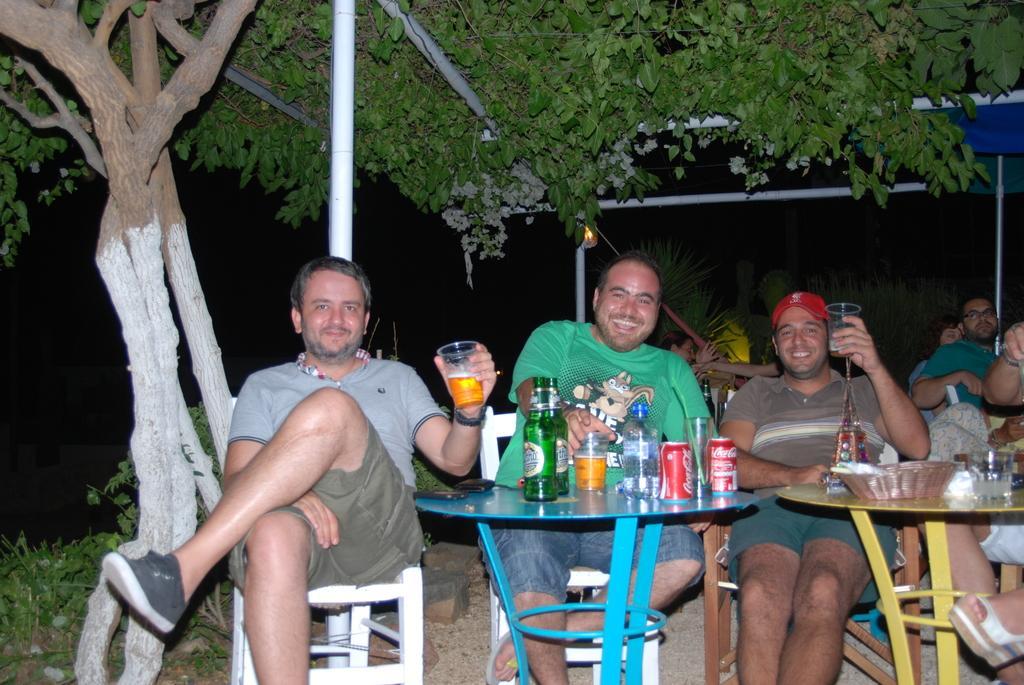Can you describe this image briefly? In this image there are group of people who are sitting on a chair and there are two tables on the tables there are some bottles, glasses, and coke containers and one basket is there. And on the background there are trees and on the bottom there are some plants and on the right side there is one tent. 